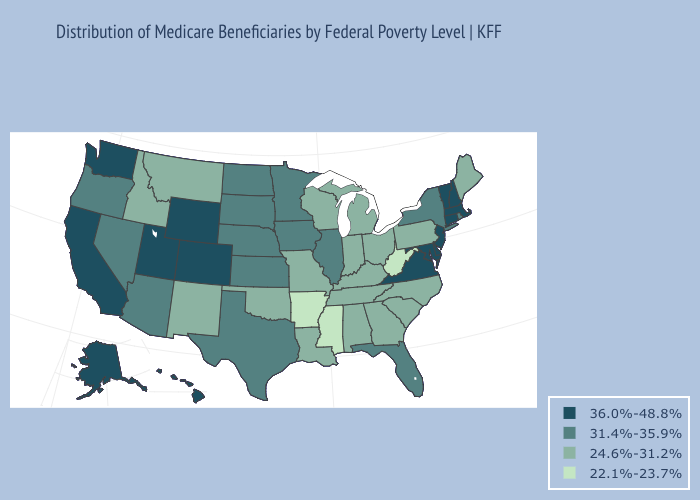What is the value of Wyoming?
Keep it brief. 36.0%-48.8%. Name the states that have a value in the range 36.0%-48.8%?
Quick response, please. Alaska, California, Colorado, Connecticut, Delaware, Hawaii, Maryland, Massachusetts, New Hampshire, New Jersey, Utah, Vermont, Virginia, Washington, Wyoming. What is the lowest value in states that border North Carolina?
Short answer required. 24.6%-31.2%. What is the highest value in the West ?
Quick response, please. 36.0%-48.8%. Name the states that have a value in the range 24.6%-31.2%?
Keep it brief. Alabama, Georgia, Idaho, Indiana, Kentucky, Louisiana, Maine, Michigan, Missouri, Montana, New Mexico, North Carolina, Ohio, Oklahoma, Pennsylvania, South Carolina, Tennessee, Wisconsin. Does Idaho have the same value as Maine?
Write a very short answer. Yes. Among the states that border Oklahoma , does Colorado have the highest value?
Concise answer only. Yes. Does the first symbol in the legend represent the smallest category?
Be succinct. No. Name the states that have a value in the range 24.6%-31.2%?
Give a very brief answer. Alabama, Georgia, Idaho, Indiana, Kentucky, Louisiana, Maine, Michigan, Missouri, Montana, New Mexico, North Carolina, Ohio, Oklahoma, Pennsylvania, South Carolina, Tennessee, Wisconsin. What is the value of Alabama?
Write a very short answer. 24.6%-31.2%. Does New Jersey have the highest value in the Northeast?
Concise answer only. Yes. Does Iowa have the highest value in the USA?
Answer briefly. No. Name the states that have a value in the range 36.0%-48.8%?
Short answer required. Alaska, California, Colorado, Connecticut, Delaware, Hawaii, Maryland, Massachusetts, New Hampshire, New Jersey, Utah, Vermont, Virginia, Washington, Wyoming. Which states hav the highest value in the Northeast?
Concise answer only. Connecticut, Massachusetts, New Hampshire, New Jersey, Vermont. What is the value of Utah?
Write a very short answer. 36.0%-48.8%. 